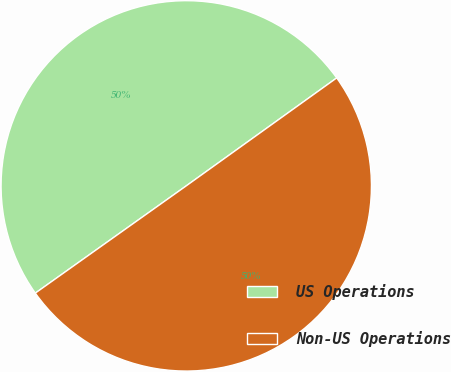Convert chart to OTSL. <chart><loc_0><loc_0><loc_500><loc_500><pie_chart><fcel>US Operations<fcel>Non-US Operations<nl><fcel>49.93%<fcel>50.07%<nl></chart> 